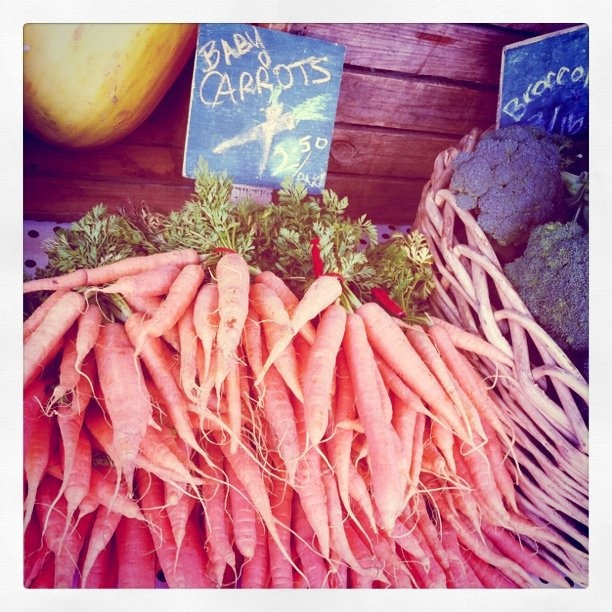Describe the objects in this image and their specific colors. I can see carrot in white, lightpink, salmon, and pink tones, broccoli in white, purple, gray, and navy tones, and broccoli in white, purple, and gray tones in this image. 